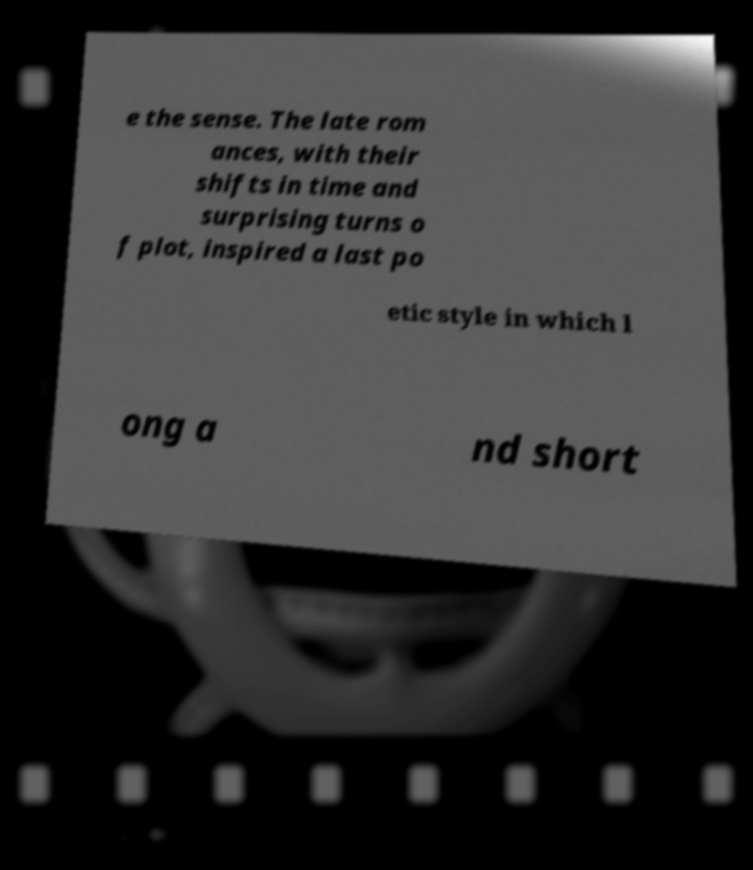Could you extract and type out the text from this image? e the sense. The late rom ances, with their shifts in time and surprising turns o f plot, inspired a last po etic style in which l ong a nd short 